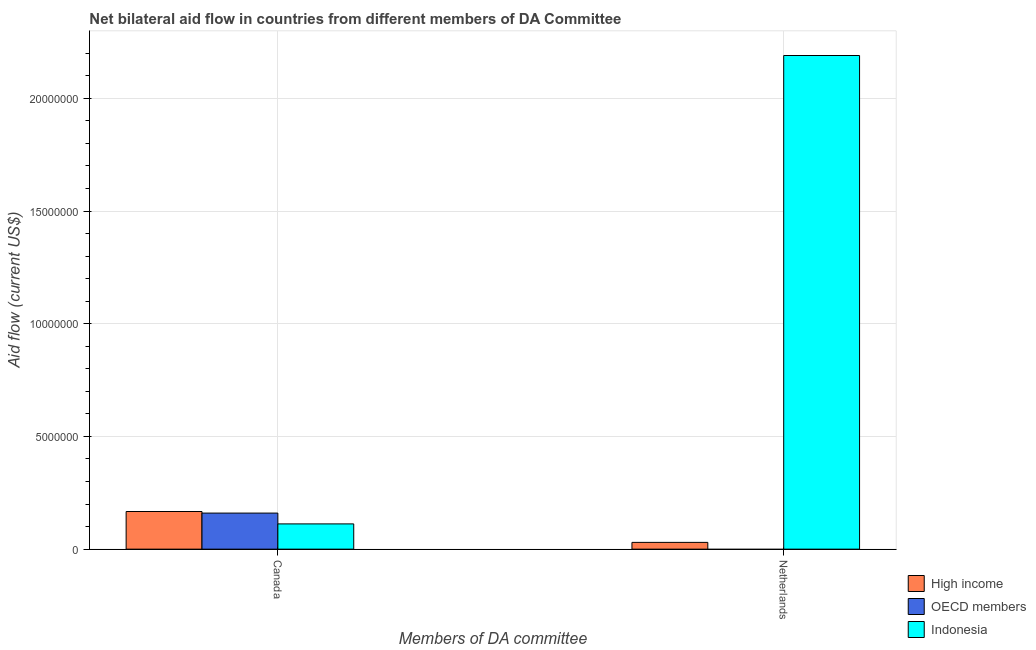How many different coloured bars are there?
Make the answer very short. 3. How many groups of bars are there?
Keep it short and to the point. 2. Are the number of bars per tick equal to the number of legend labels?
Offer a terse response. No. Are the number of bars on each tick of the X-axis equal?
Offer a very short reply. No. How many bars are there on the 1st tick from the right?
Ensure brevity in your answer.  2. What is the amount of aid given by canada in Indonesia?
Offer a very short reply. 1.12e+06. Across all countries, what is the maximum amount of aid given by canada?
Provide a short and direct response. 1.67e+06. Across all countries, what is the minimum amount of aid given by canada?
Your answer should be compact. 1.12e+06. What is the total amount of aid given by netherlands in the graph?
Your answer should be very brief. 2.22e+07. What is the difference between the amount of aid given by netherlands in High income and that in Indonesia?
Provide a short and direct response. -2.16e+07. What is the difference between the amount of aid given by netherlands in High income and the amount of aid given by canada in Indonesia?
Provide a succinct answer. -8.20e+05. What is the average amount of aid given by canada per country?
Your answer should be very brief. 1.46e+06. What is the difference between the amount of aid given by canada and amount of aid given by netherlands in Indonesia?
Ensure brevity in your answer.  -2.08e+07. In how many countries, is the amount of aid given by canada greater than 21000000 US$?
Offer a terse response. 0. What is the ratio of the amount of aid given by canada in High income to that in Indonesia?
Ensure brevity in your answer.  1.49. How many bars are there?
Ensure brevity in your answer.  5. Are all the bars in the graph horizontal?
Give a very brief answer. No. How many countries are there in the graph?
Your answer should be very brief. 3. Are the values on the major ticks of Y-axis written in scientific E-notation?
Keep it short and to the point. No. Does the graph contain grids?
Offer a very short reply. Yes. How are the legend labels stacked?
Your answer should be very brief. Vertical. What is the title of the graph?
Your answer should be compact. Net bilateral aid flow in countries from different members of DA Committee. Does "Brazil" appear as one of the legend labels in the graph?
Offer a terse response. No. What is the label or title of the X-axis?
Offer a terse response. Members of DA committee. What is the Aid flow (current US$) of High income in Canada?
Your response must be concise. 1.67e+06. What is the Aid flow (current US$) of OECD members in Canada?
Your response must be concise. 1.60e+06. What is the Aid flow (current US$) in Indonesia in Canada?
Provide a succinct answer. 1.12e+06. What is the Aid flow (current US$) in High income in Netherlands?
Offer a very short reply. 3.00e+05. What is the Aid flow (current US$) in Indonesia in Netherlands?
Make the answer very short. 2.19e+07. Across all Members of DA committee, what is the maximum Aid flow (current US$) of High income?
Provide a succinct answer. 1.67e+06. Across all Members of DA committee, what is the maximum Aid flow (current US$) of OECD members?
Your response must be concise. 1.60e+06. Across all Members of DA committee, what is the maximum Aid flow (current US$) of Indonesia?
Your response must be concise. 2.19e+07. Across all Members of DA committee, what is the minimum Aid flow (current US$) in OECD members?
Provide a succinct answer. 0. Across all Members of DA committee, what is the minimum Aid flow (current US$) of Indonesia?
Ensure brevity in your answer.  1.12e+06. What is the total Aid flow (current US$) in High income in the graph?
Give a very brief answer. 1.97e+06. What is the total Aid flow (current US$) in OECD members in the graph?
Your answer should be compact. 1.60e+06. What is the total Aid flow (current US$) in Indonesia in the graph?
Provide a short and direct response. 2.30e+07. What is the difference between the Aid flow (current US$) in High income in Canada and that in Netherlands?
Ensure brevity in your answer.  1.37e+06. What is the difference between the Aid flow (current US$) of Indonesia in Canada and that in Netherlands?
Offer a terse response. -2.08e+07. What is the difference between the Aid flow (current US$) of High income in Canada and the Aid flow (current US$) of Indonesia in Netherlands?
Give a very brief answer. -2.02e+07. What is the difference between the Aid flow (current US$) of OECD members in Canada and the Aid flow (current US$) of Indonesia in Netherlands?
Your response must be concise. -2.03e+07. What is the average Aid flow (current US$) in High income per Members of DA committee?
Your answer should be very brief. 9.85e+05. What is the average Aid flow (current US$) in Indonesia per Members of DA committee?
Offer a very short reply. 1.15e+07. What is the difference between the Aid flow (current US$) in OECD members and Aid flow (current US$) in Indonesia in Canada?
Make the answer very short. 4.80e+05. What is the difference between the Aid flow (current US$) in High income and Aid flow (current US$) in Indonesia in Netherlands?
Your answer should be very brief. -2.16e+07. What is the ratio of the Aid flow (current US$) in High income in Canada to that in Netherlands?
Your response must be concise. 5.57. What is the ratio of the Aid flow (current US$) in Indonesia in Canada to that in Netherlands?
Your answer should be compact. 0.05. What is the difference between the highest and the second highest Aid flow (current US$) of High income?
Provide a succinct answer. 1.37e+06. What is the difference between the highest and the second highest Aid flow (current US$) of Indonesia?
Offer a very short reply. 2.08e+07. What is the difference between the highest and the lowest Aid flow (current US$) of High income?
Provide a short and direct response. 1.37e+06. What is the difference between the highest and the lowest Aid flow (current US$) in OECD members?
Your response must be concise. 1.60e+06. What is the difference between the highest and the lowest Aid flow (current US$) in Indonesia?
Provide a short and direct response. 2.08e+07. 